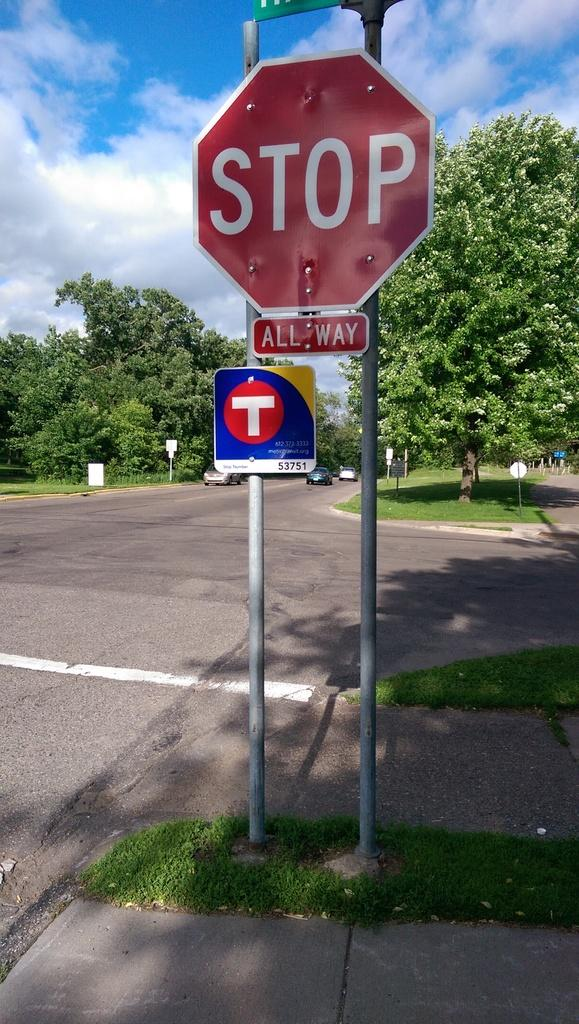<image>
Summarize the visual content of the image. A red and white stop sign with a smaller sign that reads all way on the bottom of it. 